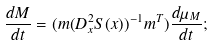Convert formula to latex. <formula><loc_0><loc_0><loc_500><loc_500>\frac { d M } { d t } = ( m ( D ^ { 2 } _ { x } S ( x ) ) ^ { - 1 } m ^ { T } ) \frac { d \mu _ { M } } { d t } ;</formula> 